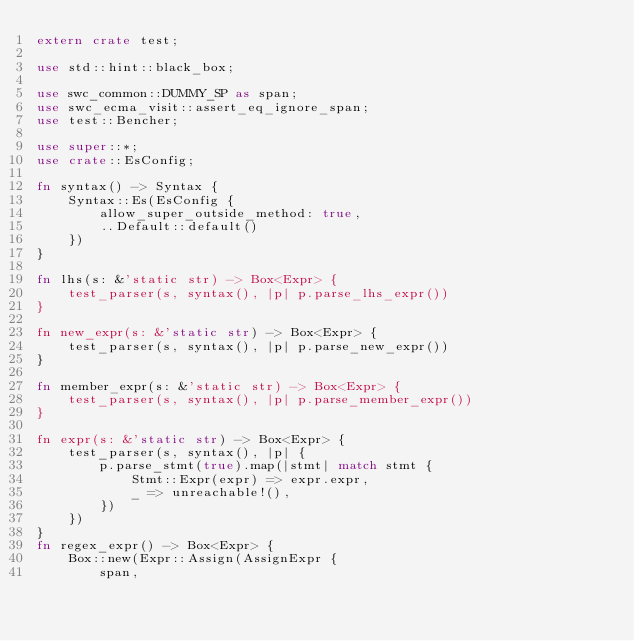<code> <loc_0><loc_0><loc_500><loc_500><_Rust_>extern crate test;

use std::hint::black_box;

use swc_common::DUMMY_SP as span;
use swc_ecma_visit::assert_eq_ignore_span;
use test::Bencher;

use super::*;
use crate::EsConfig;

fn syntax() -> Syntax {
    Syntax::Es(EsConfig {
        allow_super_outside_method: true,
        ..Default::default()
    })
}

fn lhs(s: &'static str) -> Box<Expr> {
    test_parser(s, syntax(), |p| p.parse_lhs_expr())
}

fn new_expr(s: &'static str) -> Box<Expr> {
    test_parser(s, syntax(), |p| p.parse_new_expr())
}

fn member_expr(s: &'static str) -> Box<Expr> {
    test_parser(s, syntax(), |p| p.parse_member_expr())
}

fn expr(s: &'static str) -> Box<Expr> {
    test_parser(s, syntax(), |p| {
        p.parse_stmt(true).map(|stmt| match stmt {
            Stmt::Expr(expr) => expr.expr,
            _ => unreachable!(),
        })
    })
}
fn regex_expr() -> Box<Expr> {
    Box::new(Expr::Assign(AssignExpr {
        span,</code> 